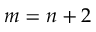Convert formula to latex. <formula><loc_0><loc_0><loc_500><loc_500>m = n + 2</formula> 